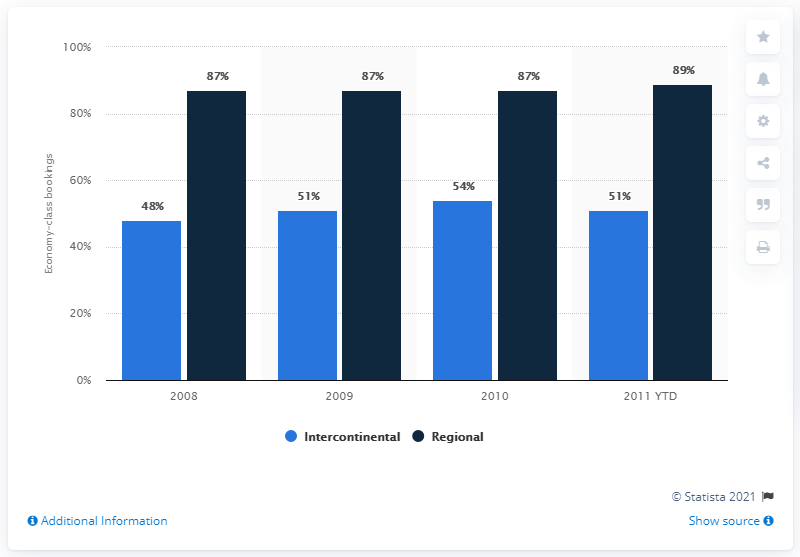Point out several critical features in this image. In 2008, regional economy-class bookings accounted for approximately 87% of total bookings. The average value of Intercontinental economy-class bookings from 2009 to 2010 was 52.5. 